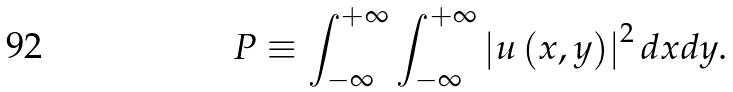Convert formula to latex. <formula><loc_0><loc_0><loc_500><loc_500>P \equiv \int _ { - \infty } ^ { + \infty } \int _ { - \infty } ^ { + \infty } \left | u \left ( x , y \right ) \right | ^ { 2 } d x d y .</formula> 